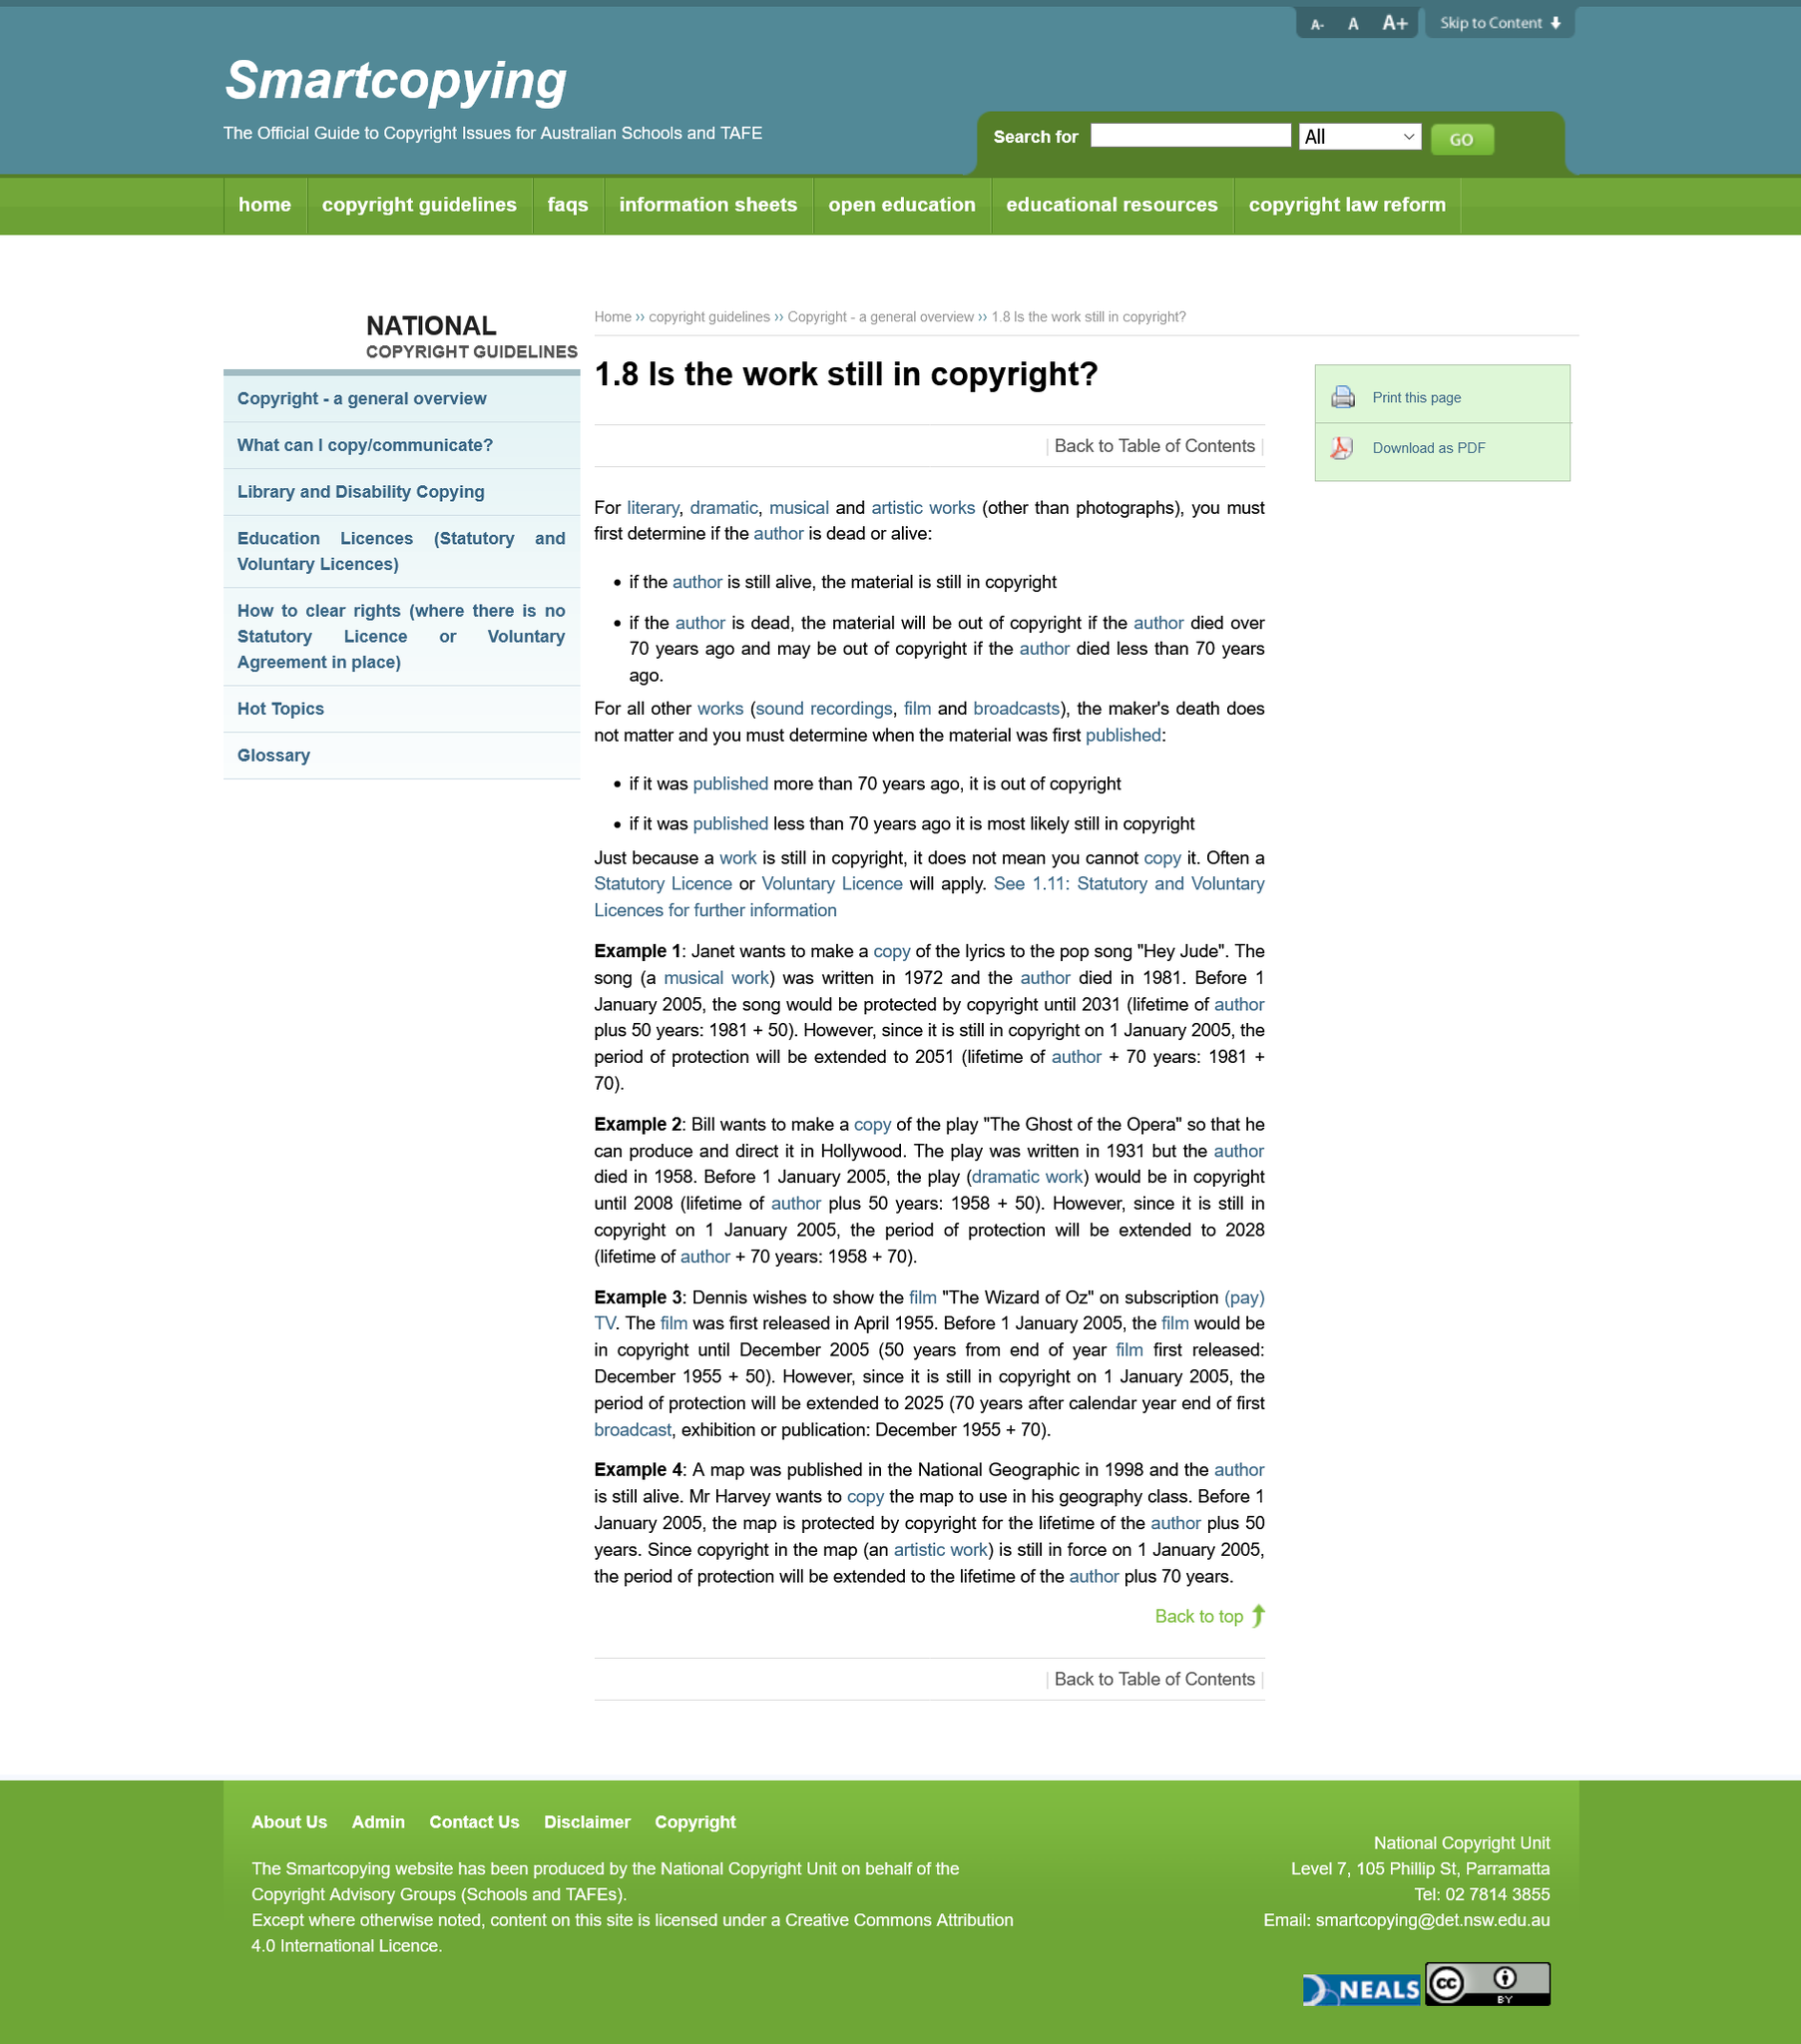Highlight a few significant elements in this photo. The death of the maker of a sound recording does not affect its legal ownership or copyright status. If the author is still alive, then the material is still under copyright. Yes, it is possible for a work to be under copyright if either the author is dead or the author is not. 